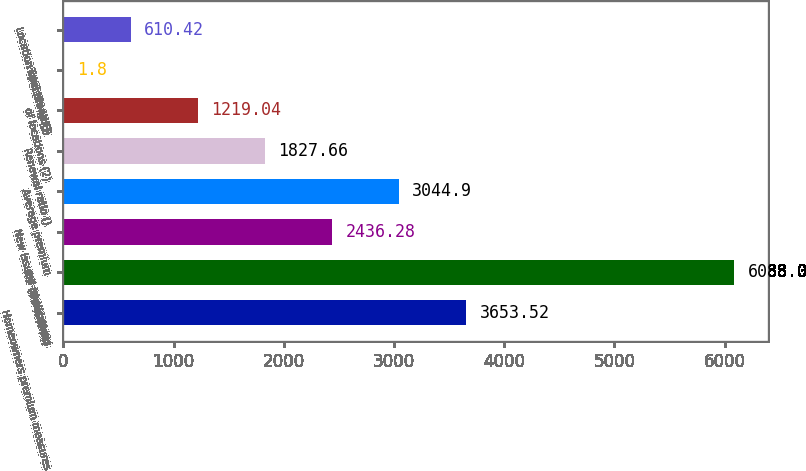<chart> <loc_0><loc_0><loc_500><loc_500><bar_chart><fcel>Homeowners premium measures<fcel>PIF (thousands)<fcel>New issued applications<fcel>Average premium<fcel>Renewal ratio ()<fcel>of locations (2)<fcel>Total brand ()<fcel>Location specific () (3)<nl><fcel>3653.52<fcel>6088<fcel>2436.28<fcel>3044.9<fcel>1827.66<fcel>1219.04<fcel>1.8<fcel>610.42<nl></chart> 